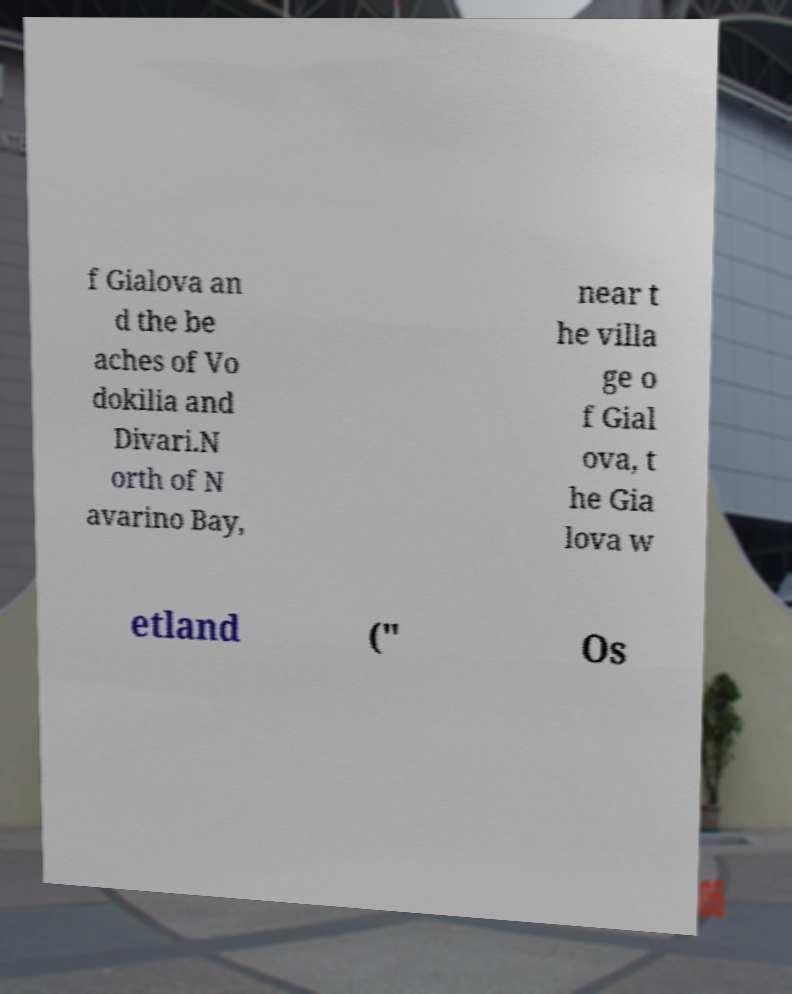Can you accurately transcribe the text from the provided image for me? f Gialova an d the be aches of Vo dokilia and Divari.N orth of N avarino Bay, near t he villa ge o f Gial ova, t he Gia lova w etland (" Os 